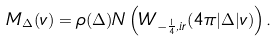<formula> <loc_0><loc_0><loc_500><loc_500>M _ { \Delta } ( v ) = \rho ( \Delta ) N \left ( W _ { - \frac { 1 } { 4 } , i r } ( 4 \pi | \Delta | v ) \right ) .</formula> 